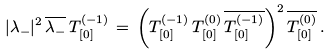<formula> <loc_0><loc_0><loc_500><loc_500>| \lambda _ { - } | ^ { 2 } \, \overline { { { \lambda _ { - } } } } \, T _ { [ 0 ] } ^ { ( - 1 ) } \, = \, \left ( T _ { [ 0 ] } ^ { ( - 1 ) } \, T _ { [ 0 ] } ^ { ( 0 ) } \, \overline { { { T _ { [ 0 ] } ^ { ( - 1 ) } } } } \right ) ^ { 2 } \overline { { { T _ { [ 0 ] } ^ { ( 0 ) } } } } \, .</formula> 